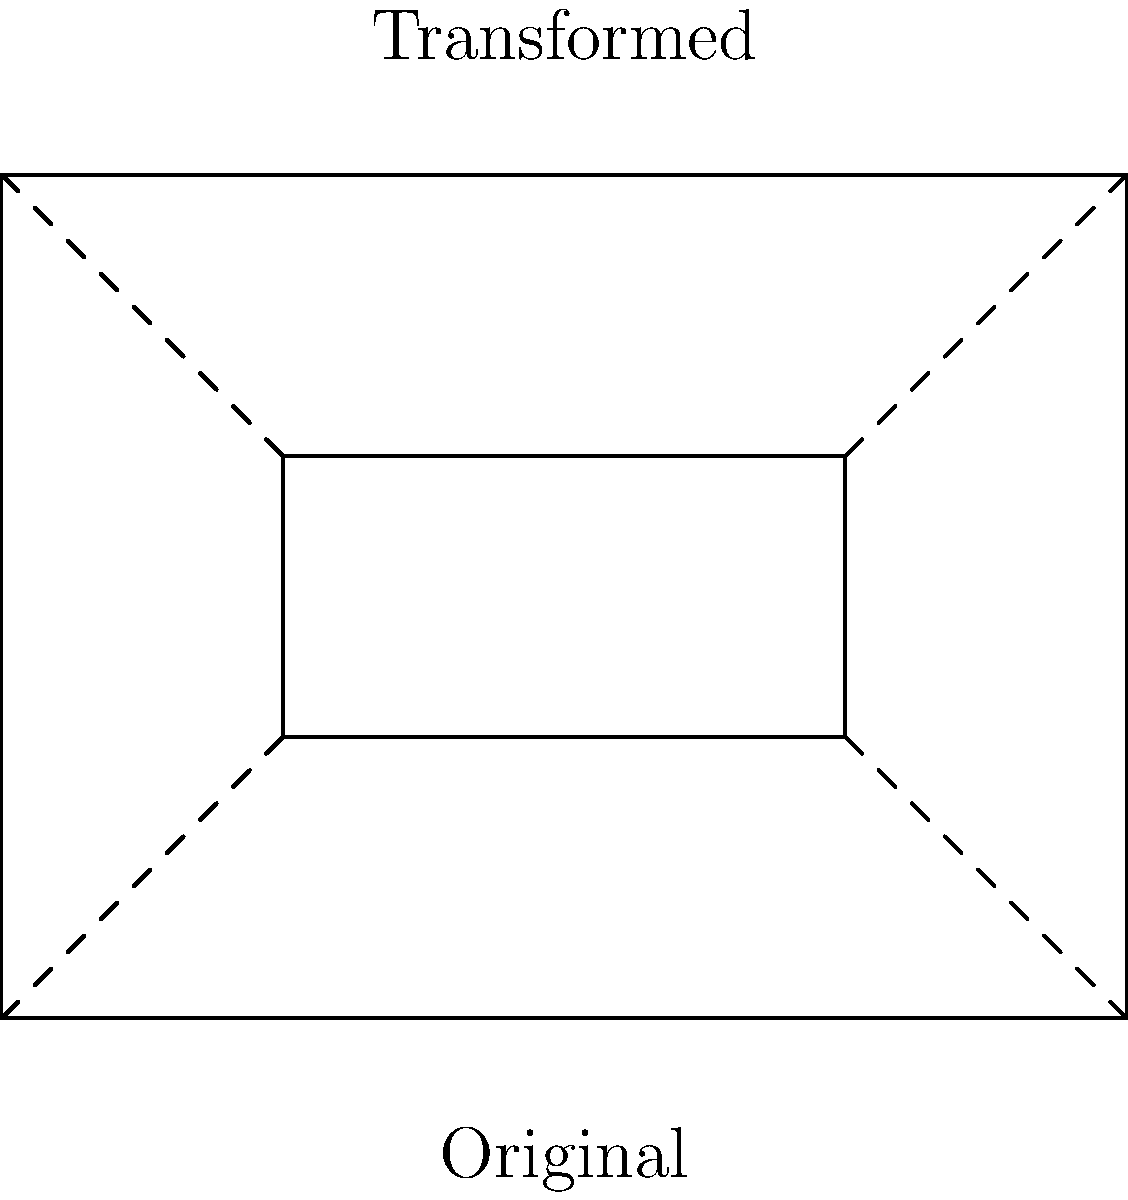In the context of cinema and philosophy, how does the transformation of the rectangle in the diagram relate to the concept of shifting perspectives in philosophical arguments? Describe the specific transformation shown and its philosophical implications. 1. Geometric Transformation: The diagram shows a rectangle undergoing a transformation. The original rectangle ABCD is transformed into a smaller rectangle A1B1C1D1 within it.

2. Type of Transformation: This is an example of a perspective transformation, specifically a combination of translation and scaling.

3. Translation: The rectangle has moved inward, as evidenced by the dashed lines connecting corresponding vertices.

4. Scaling: The transformed rectangle is smaller than the original, indicating a reduction in size.

5. Philosophical Interpretation: In philosophy, this transformation can be seen as an analogy for shifting perspectives or narrowing focus in an argument.

6. Cinematic Parallel: In film, this transformation is similar to a camera zooming in on a subject, changing the viewer's perspective and focus.

7. Philosophical Implication: Just as the transformed rectangle presents a more focused view within the larger context, philosophical arguments often involve narrowing broad concepts to specific points of analysis.

8. Relational Aspect: The transformed rectangle maintains its proportional relationship to the original, suggesting that even as perspectives shift, core relationships in philosophical arguments often remain intact.

9. Boundaries and Limitations: The transformation shows how adopting a new perspective (represented by the inner rectangle) can reveal new insights but also imposes new limitations (the boundaries of the smaller rectangle).

10. Multidimensional Thinking: This visual representation encourages considering multiple viewpoints simultaneously, a crucial skill in both philosophical discourse and film analysis.
Answer: Perspective transformation representing focused analysis within broader context 